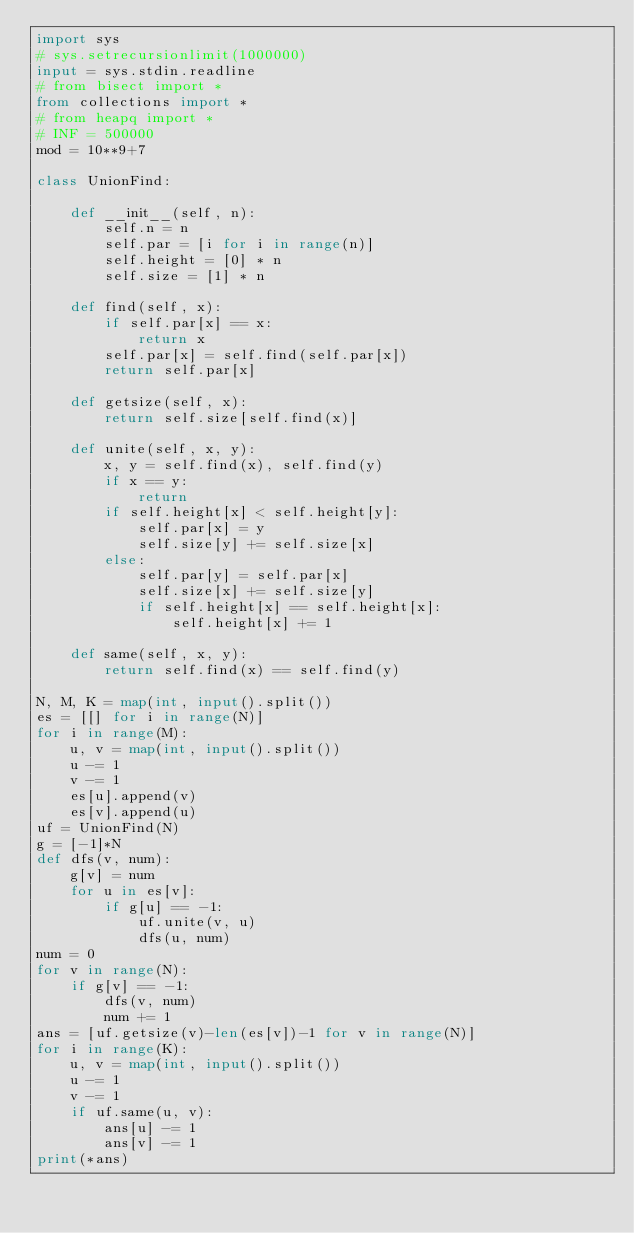<code> <loc_0><loc_0><loc_500><loc_500><_Python_>import sys
# sys.setrecursionlimit(1000000)
input = sys.stdin.readline
# from bisect import *
from collections import *
# from heapq import *
# INF = 500000
mod = 10**9+7

class UnionFind:

    def __init__(self, n):
        self.n = n
        self.par = [i for i in range(n)]
        self.height = [0] * n
        self.size = [1] * n

    def find(self, x):
        if self.par[x] == x:
            return x
        self.par[x] = self.find(self.par[x])
        return self.par[x]

    def getsize(self, x):
        return self.size[self.find(x)]

    def unite(self, x, y):
        x, y = self.find(x), self.find(y)
        if x == y:
            return
        if self.height[x] < self.height[y]:
            self.par[x] = y
            self.size[y] += self.size[x]
        else:
            self.par[y] = self.par[x]
            self.size[x] += self.size[y]
            if self.height[x] == self.height[x]:
                self.height[x] += 1

    def same(self, x, y):
        return self.find(x) == self.find(y)

N, M, K = map(int, input().split())
es = [[] for i in range(N)]
for i in range(M):
    u, v = map(int, input().split())
    u -= 1
    v -= 1
    es[u].append(v)
    es[v].append(u)
uf = UnionFind(N)
g = [-1]*N
def dfs(v, num):
    g[v] = num
    for u in es[v]:
        if g[u] == -1:
            uf.unite(v, u)
            dfs(u, num)
num = 0
for v in range(N):
    if g[v] == -1:
        dfs(v, num)
        num += 1
ans = [uf.getsize(v)-len(es[v])-1 for v in range(N)]
for i in range(K):
    u, v = map(int, input().split())
    u -= 1
    v -= 1
    if uf.same(u, v):
        ans[u] -= 1
        ans[v] -= 1
print(*ans)
</code> 